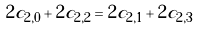Convert formula to latex. <formula><loc_0><loc_0><loc_500><loc_500>2 c _ { 2 , 0 } + 2 c _ { 2 , 2 } = 2 c _ { 2 , 1 } + 2 c _ { 2 , 3 }</formula> 